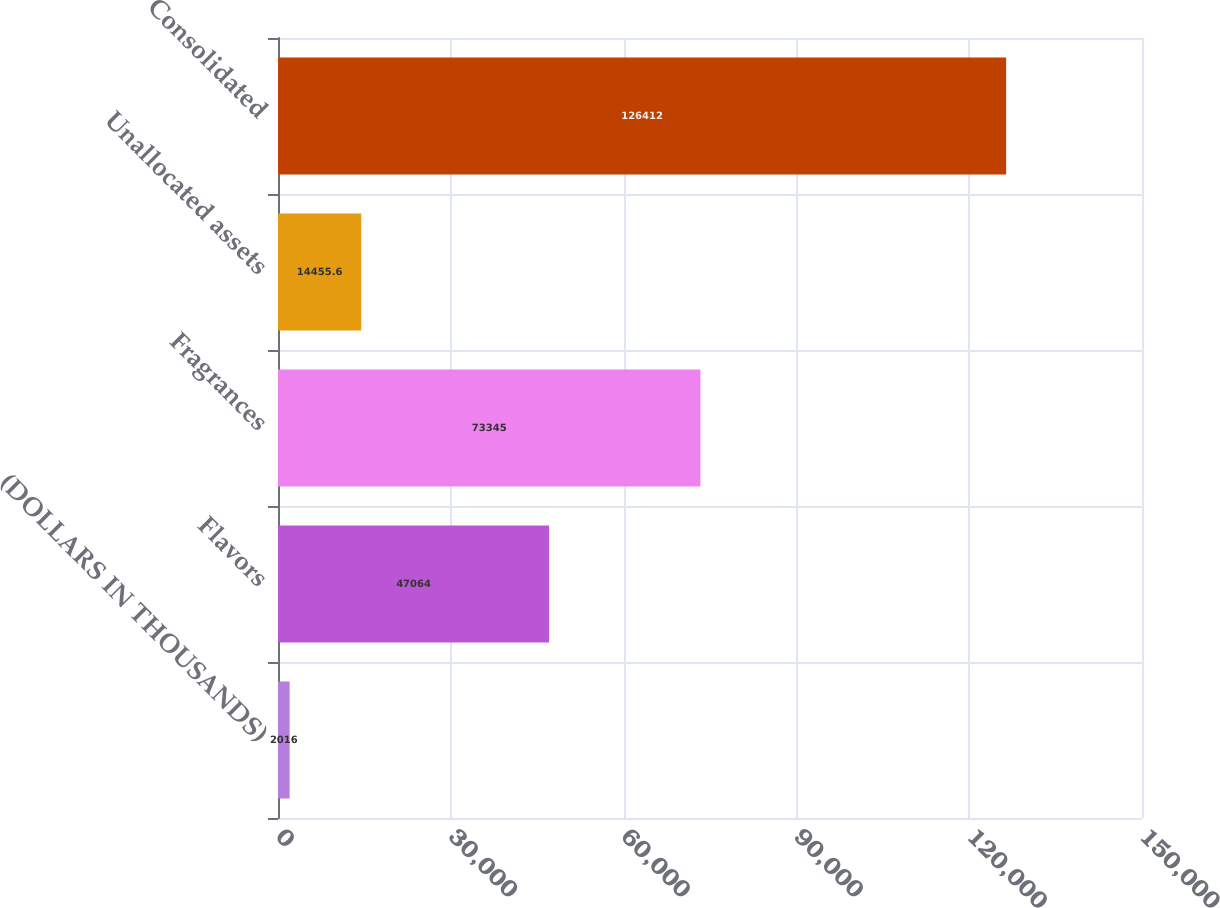<chart> <loc_0><loc_0><loc_500><loc_500><bar_chart><fcel>(DOLLARS IN THOUSANDS)<fcel>Flavors<fcel>Fragrances<fcel>Unallocated assets<fcel>Consolidated<nl><fcel>2016<fcel>47064<fcel>73345<fcel>14455.6<fcel>126412<nl></chart> 